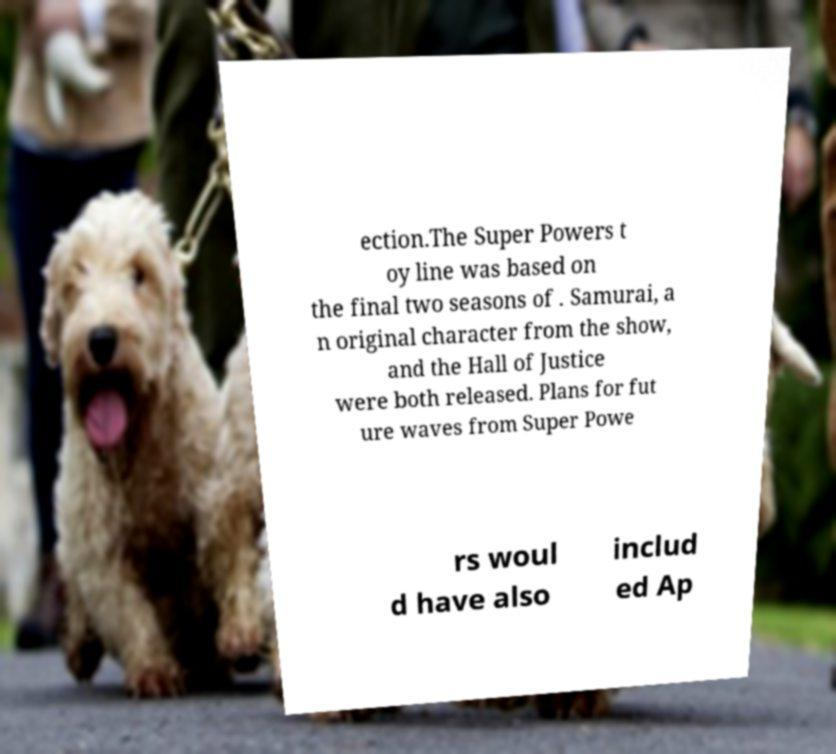What messages or text are displayed in this image? I need them in a readable, typed format. ection.The Super Powers t oy line was based on the final two seasons of . Samurai, a n original character from the show, and the Hall of Justice were both released. Plans for fut ure waves from Super Powe rs woul d have also includ ed Ap 